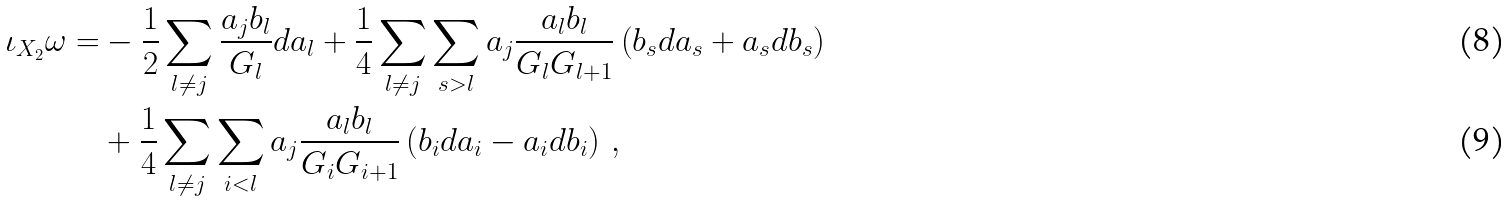<formula> <loc_0><loc_0><loc_500><loc_500>\iota _ { X _ { 2 } } \omega = & - \frac { 1 } { 2 } \sum _ { l \neq j } \frac { a _ { j } b _ { l } } { G _ { l } } d a _ { l } + \frac { 1 } { 4 } \sum _ { l \neq j } \sum _ { s > l } a _ { j } \frac { a _ { l } b _ { l } } { G _ { l } G _ { l + 1 } } \left ( b _ { s } d a _ { s } + a _ { s } d b _ { s } \right ) \\ & + \frac { 1 } { 4 } \sum _ { l \neq j } \sum _ { i < l } a _ { j } \frac { a _ { l } b _ { l } } { G _ { i } G _ { i + 1 } } \left ( b _ { i } d a _ { i } - a _ { i } d b _ { i } \right ) \, ,</formula> 